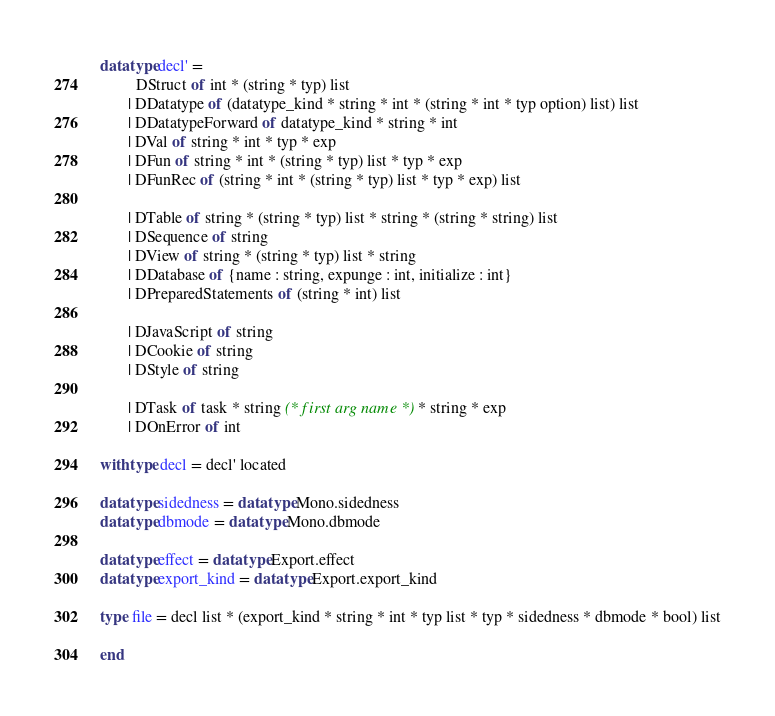<code> <loc_0><loc_0><loc_500><loc_500><_SML_>
datatype decl' =
         DStruct of int * (string * typ) list
       | DDatatype of (datatype_kind * string * int * (string * int * typ option) list) list
       | DDatatypeForward of datatype_kind * string * int
       | DVal of string * int * typ * exp
       | DFun of string * int * (string * typ) list * typ * exp
       | DFunRec of (string * int * (string * typ) list * typ * exp) list

       | DTable of string * (string * typ) list * string * (string * string) list
       | DSequence of string
       | DView of string * (string * typ) list * string
       | DDatabase of {name : string, expunge : int, initialize : int}
       | DPreparedStatements of (string * int) list

       | DJavaScript of string
       | DCookie of string
       | DStyle of string

       | DTask of task * string (* first arg name *) * string * exp
       | DOnError of int

withtype decl = decl' located

datatype sidedness = datatype Mono.sidedness
datatype dbmode = datatype Mono.dbmode

datatype effect = datatype Export.effect
datatype export_kind = datatype Export.export_kind

type file = decl list * (export_kind * string * int * typ list * typ * sidedness * dbmode * bool) list

end
</code> 